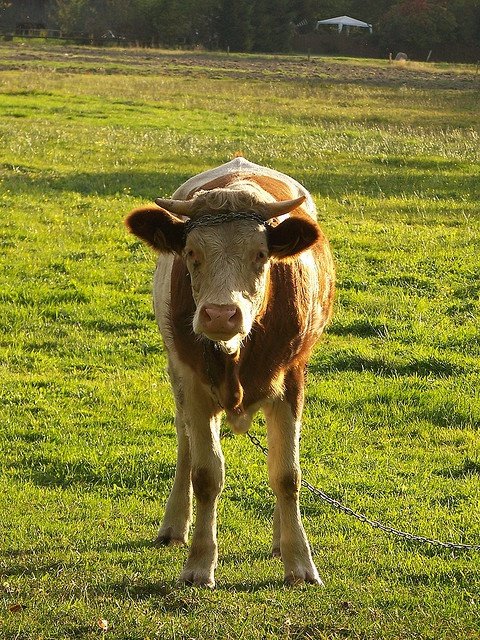Describe the objects in this image and their specific colors. I can see a cow in black, olive, maroon, and beige tones in this image. 